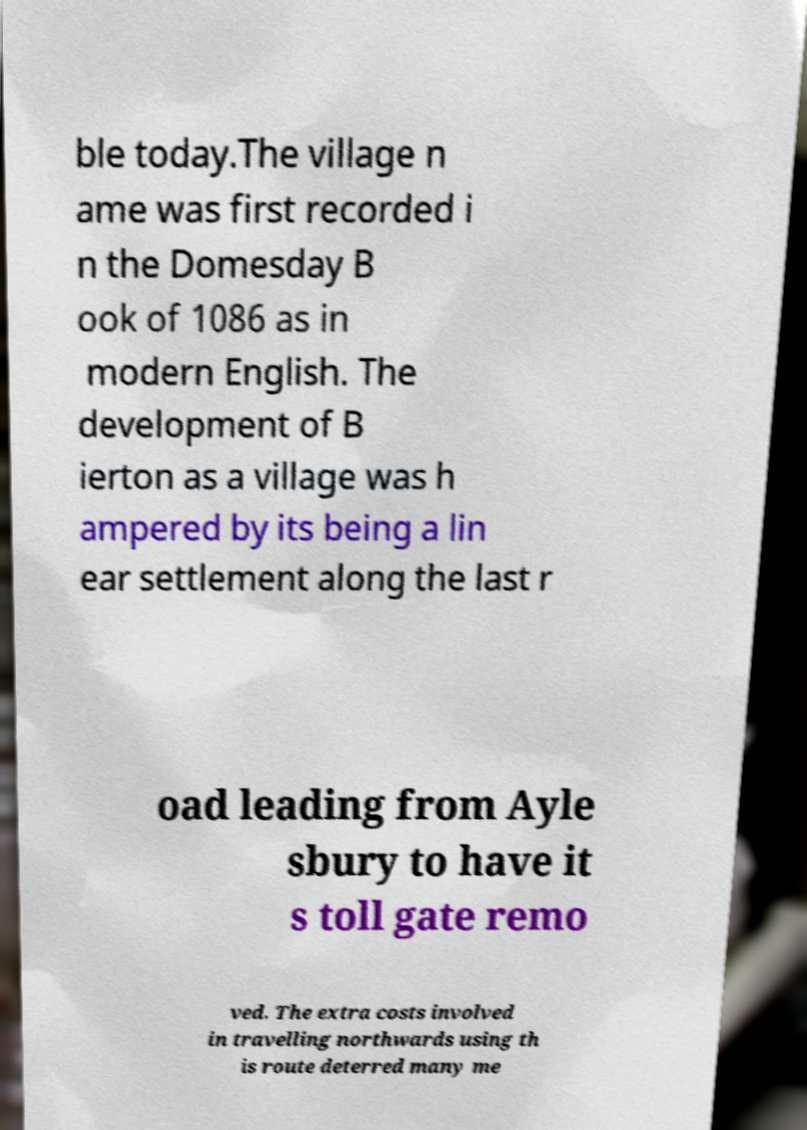Can you read and provide the text displayed in the image?This photo seems to have some interesting text. Can you extract and type it out for me? ble today.The village n ame was first recorded i n the Domesday B ook of 1086 as in modern English. The development of B ierton as a village was h ampered by its being a lin ear settlement along the last r oad leading from Ayle sbury to have it s toll gate remo ved. The extra costs involved in travelling northwards using th is route deterred many me 